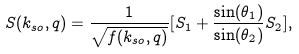<formula> <loc_0><loc_0><loc_500><loc_500>S ( k _ { s o } , q ) = \frac { 1 } { \sqrt { f ( k _ { s o } , q ) } } [ S _ { 1 } + \frac { \sin ( \theta _ { 1 } ) } { \sin ( \theta _ { 2 } ) } S _ { 2 } ] ,</formula> 